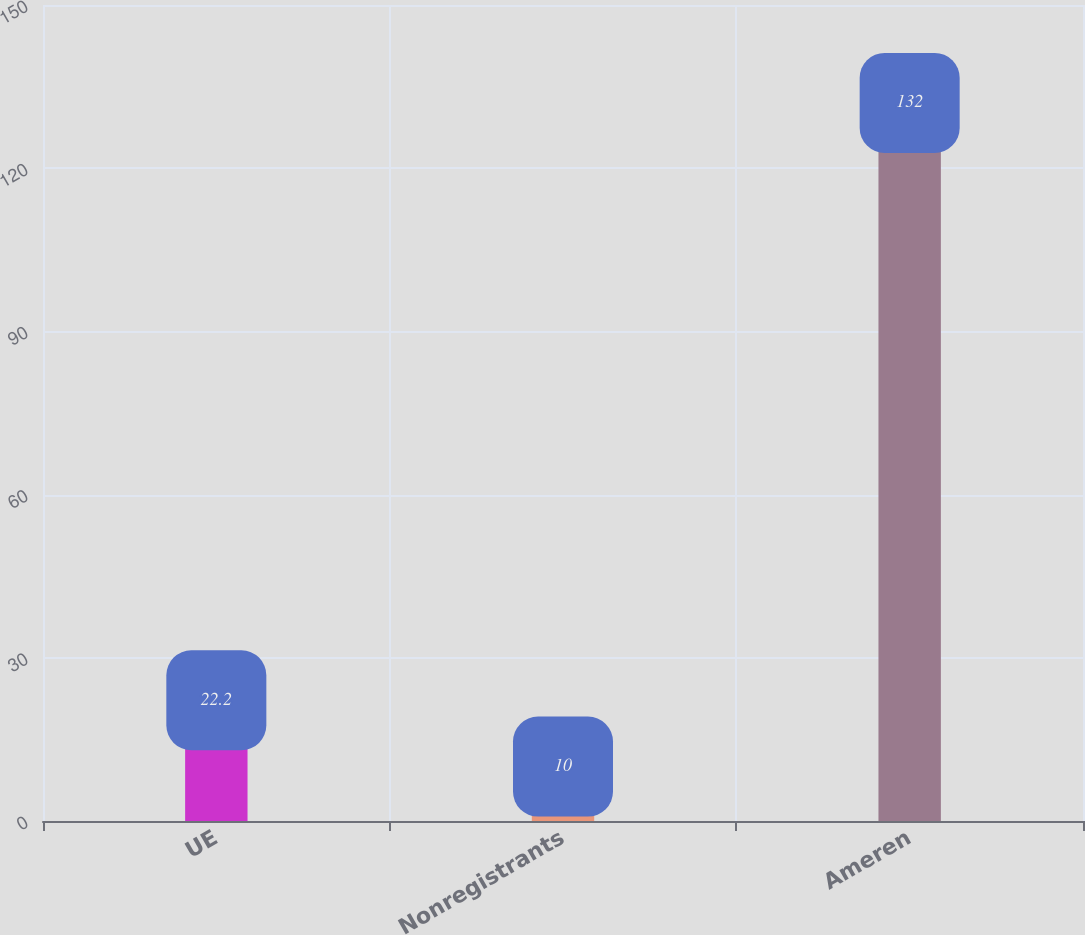Convert chart. <chart><loc_0><loc_0><loc_500><loc_500><bar_chart><fcel>UE<fcel>Nonregistrants<fcel>Ameren<nl><fcel>22.2<fcel>10<fcel>132<nl></chart> 